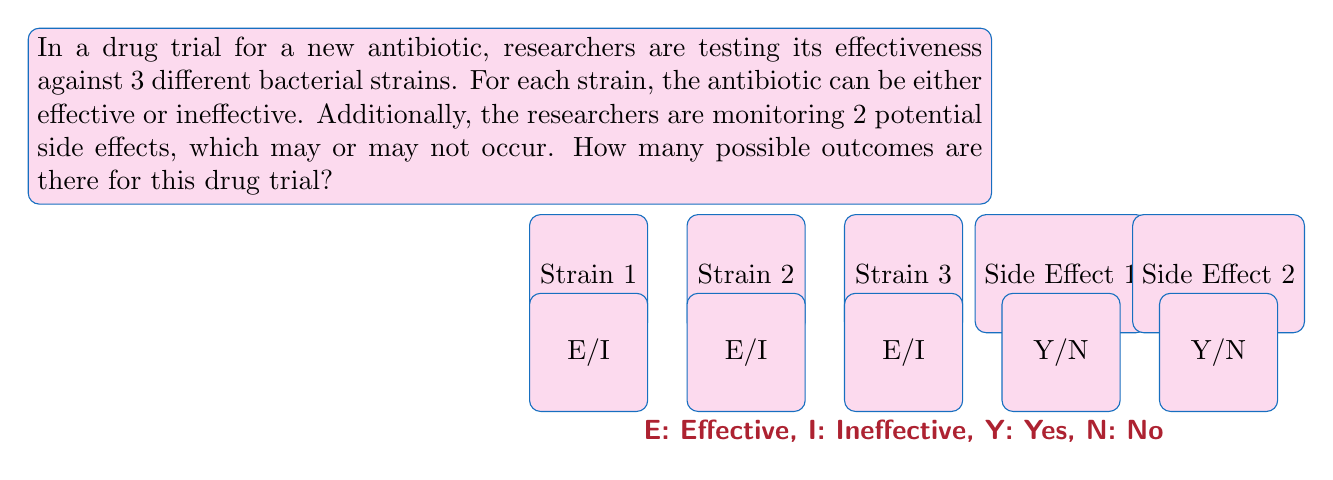Help me with this question. Let's approach this step-by-step using the multiplication principle of combinatorics:

1) For each bacterial strain, there are 2 possible outcomes:
   - Effective (E)
   - Ineffective (I)

2) There are 3 bacterial strains, so for the antibiotic effectiveness, we have:
   $2 \times 2 \times 2 = 2^3$ possible outcomes

3) For each side effect, there are 2 possible outcomes:
   - Yes (Y)
   - No (N)

4) There are 2 side effects, so for the side effects, we have:
   $2 \times 2 = 2^2$ possible outcomes

5) To get the total number of possible outcomes, we multiply the number of possibilities for antibiotic effectiveness with the number of possibilities for side effects:

   $$ \text{Total outcomes} = (\text{Antibiotic outcomes}) \times (\text{Side effect outcomes}) $$
   $$ = 2^3 \times 2^2 $$
   $$ = 8 \times 4 $$
   $$ = 32 $$

Thus, there are 32 possible outcomes for this drug trial.
Answer: 32 